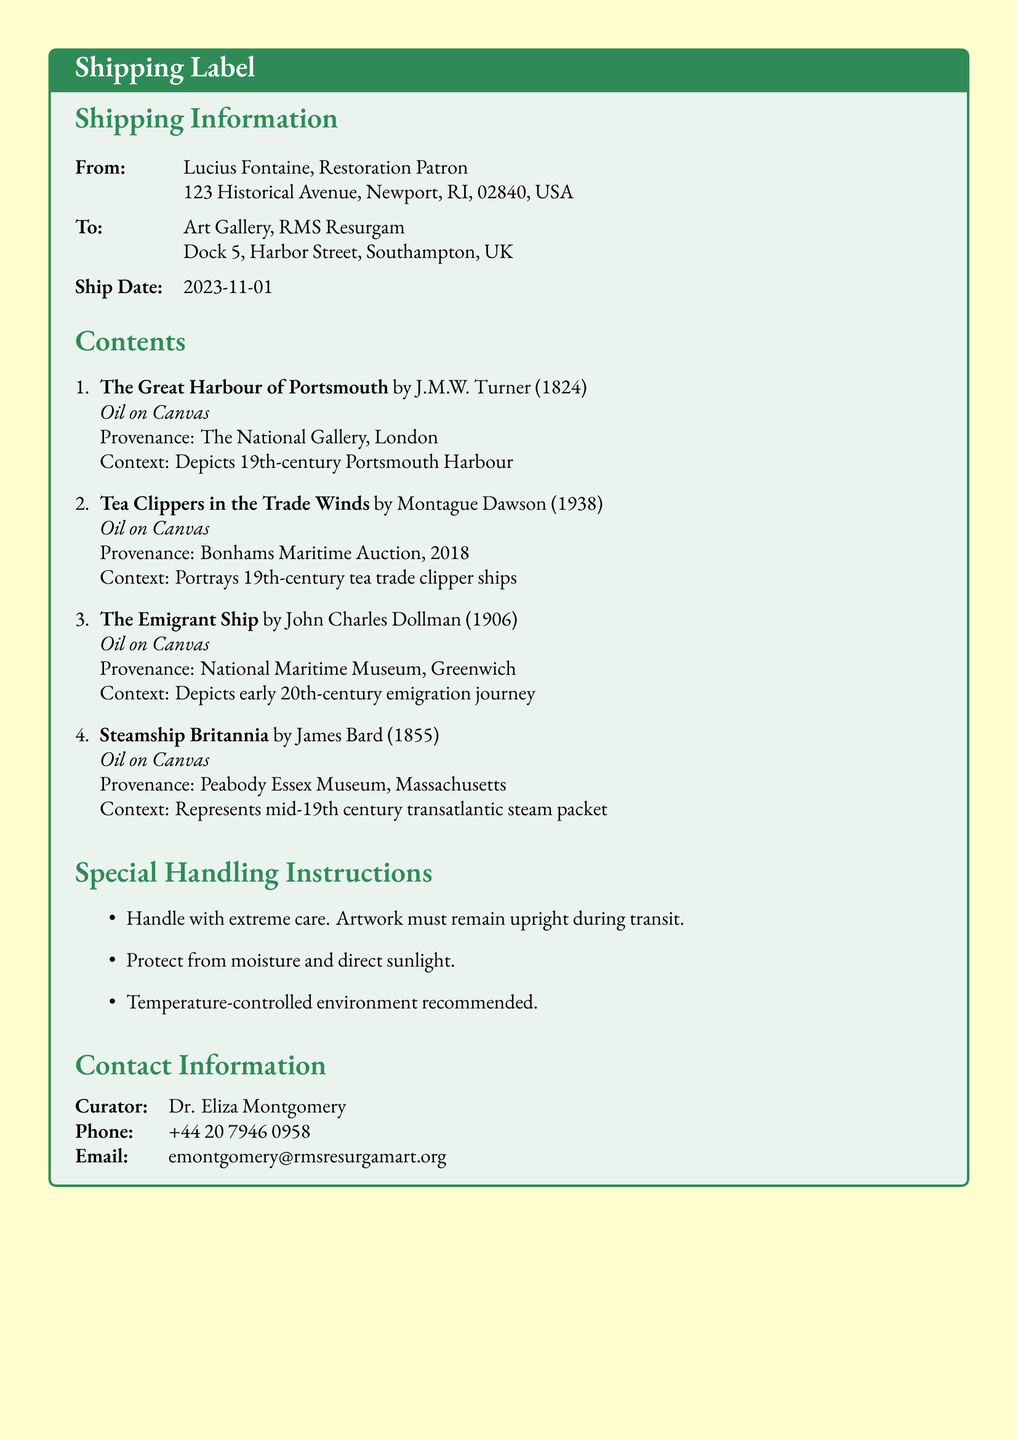What is the name of the sender? The sender's name is listed in the shipping information section, specifically under "From."
Answer: Lucius Fontaine What is the ship date? The ship date is provided in the shipping information section.
Answer: 2023-11-01 What is the provenance of "The Great Harbour of Portsmouth"? The provenance indicates where the artwork originated and is found in the contents section for that piece.
Answer: The National Gallery, London How many artworks are included in this shipment? The number of artworks is indicated by the enumeration in the contents section.
Answer: 4 What type of paint was used for "The Emigrant Ship"? The type of paint used is listed after the artwork title in the contents section.
Answer: Oil on Canvas Who is the curator of the art gallery? The curator's name is found in the contact information section of the document.
Answer: Dr. Eliza Montgomery What special instruction is noted for handling the artwork? This instruction is included in the special handling instructions section of the document.
Answer: Handle with extreme care What does "Tea Clippers in the Trade Winds" portray? The context for each artwork explains what it depicts and is located in the contents section.
Answer: 19th-century tea trade clipper ships 